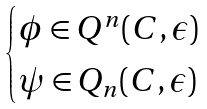Convert formula to latex. <formula><loc_0><loc_0><loc_500><loc_500>\begin{cases} \phi \in Q ^ { n } ( C , \epsilon ) \\ \psi \in Q _ { n } ( C , \epsilon ) \end{cases}</formula> 